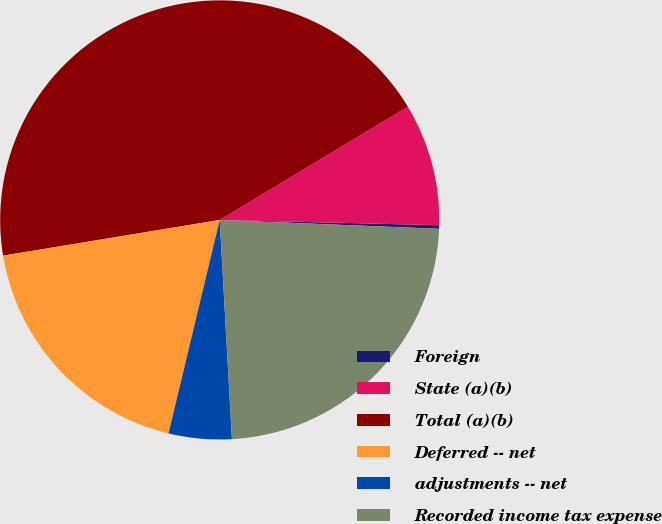Convert chart. <chart><loc_0><loc_0><loc_500><loc_500><pie_chart><fcel>Foreign<fcel>State (a)(b)<fcel>Total (a)(b)<fcel>Deferred -- net<fcel>adjustments -- net<fcel>Recorded income tax expense<nl><fcel>0.26%<fcel>9.01%<fcel>43.97%<fcel>18.65%<fcel>4.63%<fcel>23.47%<nl></chart> 